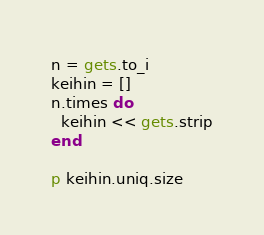Convert code to text. <code><loc_0><loc_0><loc_500><loc_500><_Ruby_>n = gets.to_i
keihin = []
n.times do
  keihin << gets.strip
end

p keihin.uniq.size</code> 